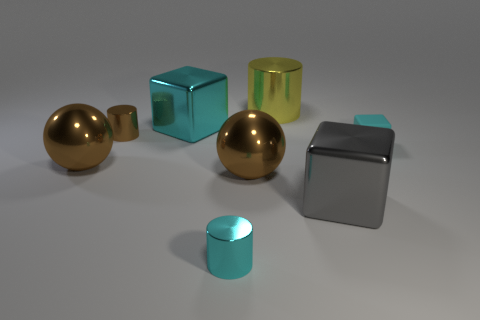What number of big brown metal balls are on the left side of the small shiny cylinder that is on the left side of the large cyan block? There is one large brown metallic sphere located to the left of a small, gleaming cylinder, which in turn is positioned to the left of a sizable cyan cube. 